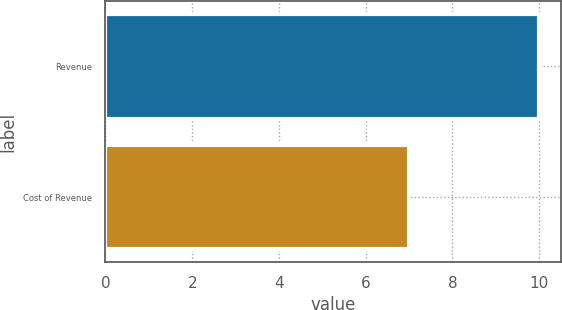Convert chart to OTSL. <chart><loc_0><loc_0><loc_500><loc_500><bar_chart><fcel>Revenue<fcel>Cost of Revenue<nl><fcel>10<fcel>7<nl></chart> 